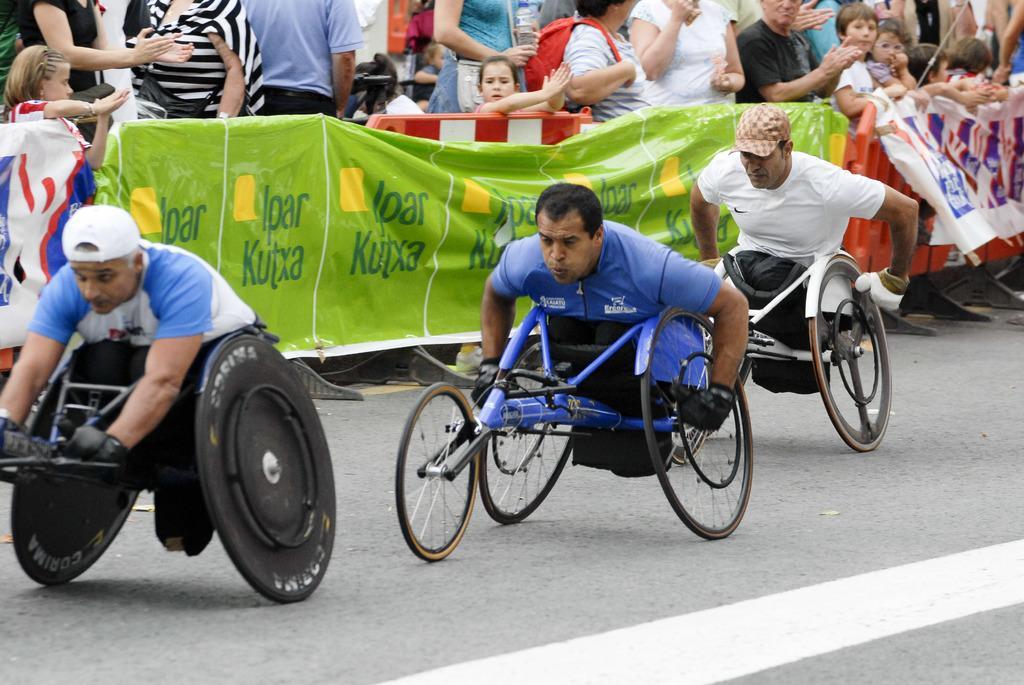Describe this image in one or two sentences. In this picture I can see three persons participating in a wheelchair racing, there are banners, barriers, and in the background there are group of people. 